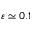Convert formula to latex. <formula><loc_0><loc_0><loc_500><loc_500>\varepsilon \simeq 0 . 1</formula> 